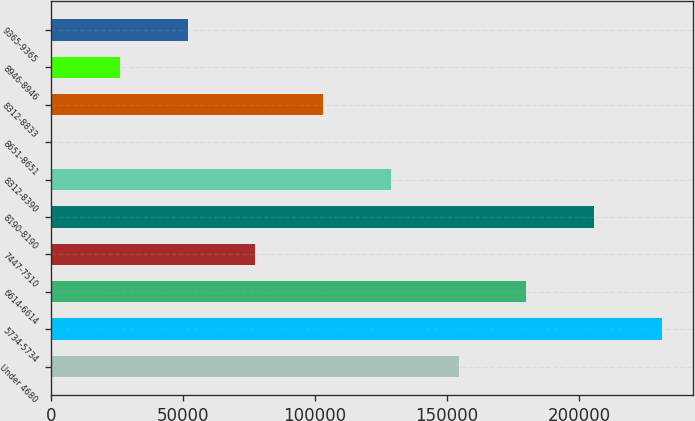<chart> <loc_0><loc_0><loc_500><loc_500><bar_chart><fcel>Under 4680<fcel>5734-5734<fcel>6614-6614<fcel>7447-7510<fcel>8190-8190<fcel>8312-8390<fcel>8651-8651<fcel>8312-8833<fcel>8946-8946<fcel>9365-9365<nl><fcel>154445<fcel>231418<fcel>180102<fcel>77472.5<fcel>205760<fcel>128788<fcel>500<fcel>103130<fcel>26157.5<fcel>51815<nl></chart> 